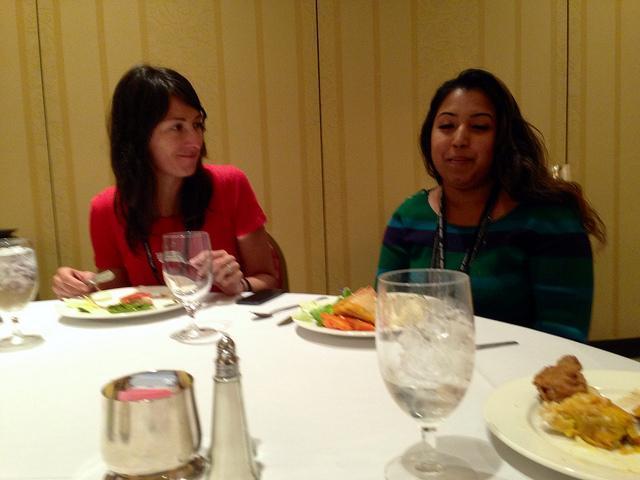How many wine glasses are on the table?
Give a very brief answer. 3. How many people are seated at the table?
Give a very brief answer. 2. How many women are pictured?
Give a very brief answer. 2. How many people are in the picture?
Give a very brief answer. 2. How many wine glasses can you see?
Give a very brief answer. 3. How many people can you see?
Give a very brief answer. 2. 